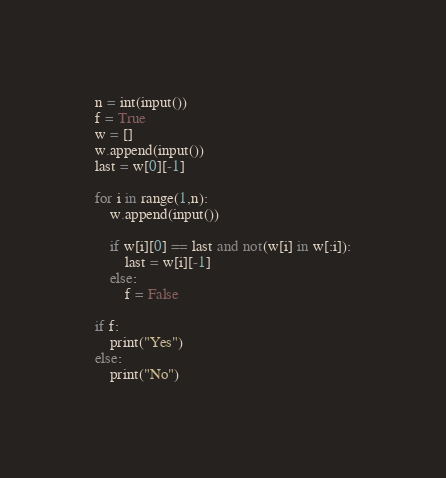<code> <loc_0><loc_0><loc_500><loc_500><_Python_>n = int(input())
f = True
w = []
w.append(input())
last = w[0][-1]

for i in range(1,n):
    w.append(input())
    
    if w[i][0] == last and not(w[i] in w[:i]):
        last = w[i][-1]
    else:
        f = False

if f:
    print("Yes")
else:
    print("No")

</code> 